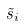Convert formula to latex. <formula><loc_0><loc_0><loc_500><loc_500>\tilde { s } _ { i }</formula> 